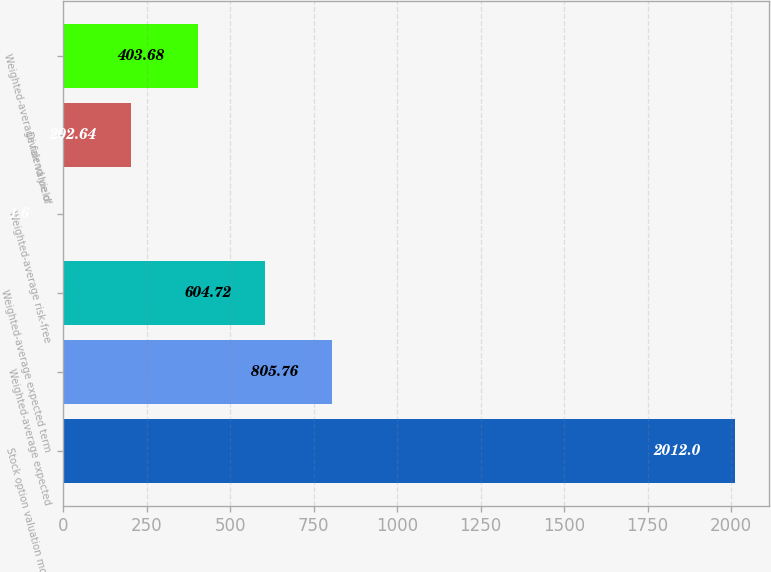Convert chart to OTSL. <chart><loc_0><loc_0><loc_500><loc_500><bar_chart><fcel>Stock option valuation model<fcel>Weighted-average expected<fcel>Weighted-average expected term<fcel>Weighted-average risk-free<fcel>Dividend yield<fcel>Weighted-average fair value of<nl><fcel>2012<fcel>805.76<fcel>604.72<fcel>1.6<fcel>202.64<fcel>403.68<nl></chart> 